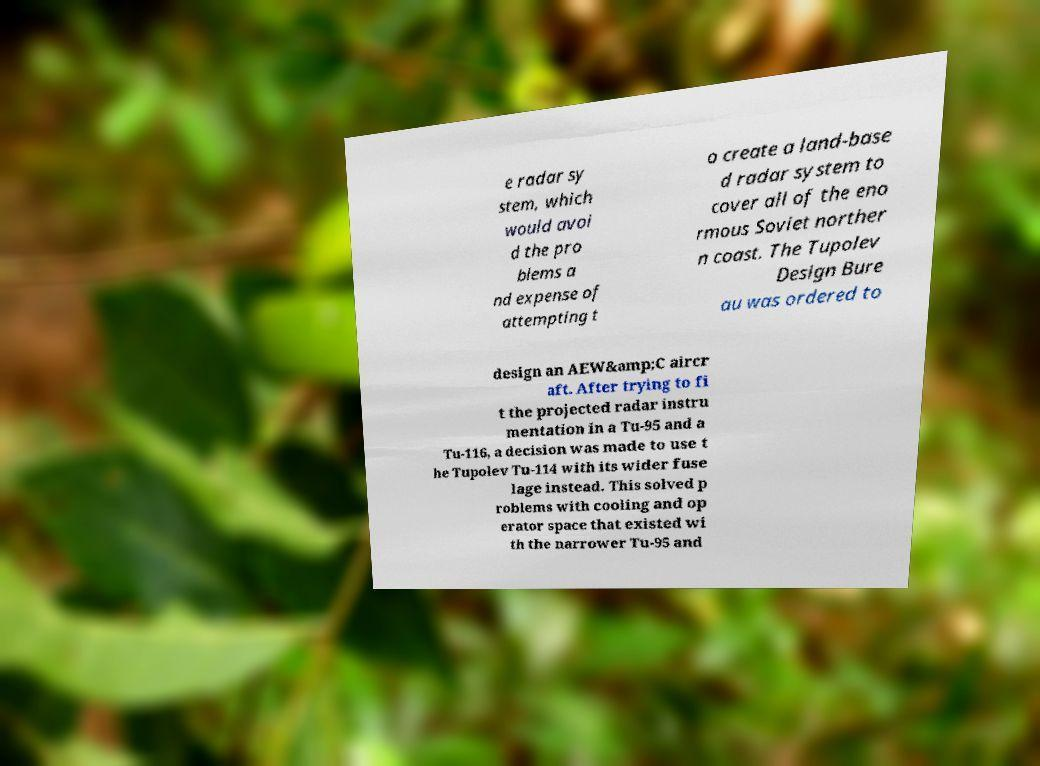Can you accurately transcribe the text from the provided image for me? e radar sy stem, which would avoi d the pro blems a nd expense of attempting t o create a land-base d radar system to cover all of the eno rmous Soviet norther n coast. The Tupolev Design Bure au was ordered to design an AEW&amp;C aircr aft. After trying to fi t the projected radar instru mentation in a Tu-95 and a Tu-116, a decision was made to use t he Tupolev Tu-114 with its wider fuse lage instead. This solved p roblems with cooling and op erator space that existed wi th the narrower Tu-95 and 